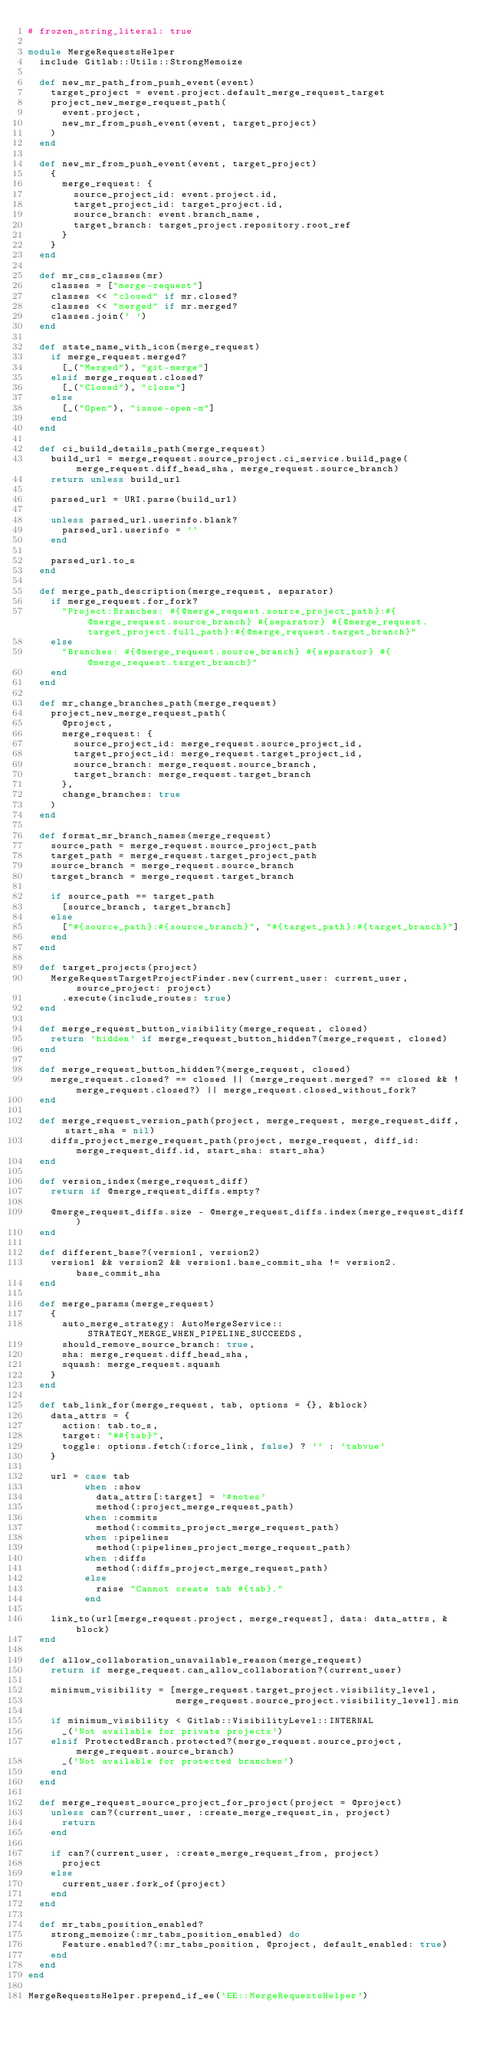Convert code to text. <code><loc_0><loc_0><loc_500><loc_500><_Ruby_># frozen_string_literal: true

module MergeRequestsHelper
  include Gitlab::Utils::StrongMemoize

  def new_mr_path_from_push_event(event)
    target_project = event.project.default_merge_request_target
    project_new_merge_request_path(
      event.project,
      new_mr_from_push_event(event, target_project)
    )
  end

  def new_mr_from_push_event(event, target_project)
    {
      merge_request: {
        source_project_id: event.project.id,
        target_project_id: target_project.id,
        source_branch: event.branch_name,
        target_branch: target_project.repository.root_ref
      }
    }
  end

  def mr_css_classes(mr)
    classes = ["merge-request"]
    classes << "closed" if mr.closed?
    classes << "merged" if mr.merged?
    classes.join(' ')
  end

  def state_name_with_icon(merge_request)
    if merge_request.merged?
      [_("Merged"), "git-merge"]
    elsif merge_request.closed?
      [_("Closed"), "close"]
    else
      [_("Open"), "issue-open-m"]
    end
  end

  def ci_build_details_path(merge_request)
    build_url = merge_request.source_project.ci_service.build_page(merge_request.diff_head_sha, merge_request.source_branch)
    return unless build_url

    parsed_url = URI.parse(build_url)

    unless parsed_url.userinfo.blank?
      parsed_url.userinfo = ''
    end

    parsed_url.to_s
  end

  def merge_path_description(merge_request, separator)
    if merge_request.for_fork?
      "Project:Branches: #{@merge_request.source_project_path}:#{@merge_request.source_branch} #{separator} #{@merge_request.target_project.full_path}:#{@merge_request.target_branch}"
    else
      "Branches: #{@merge_request.source_branch} #{separator} #{@merge_request.target_branch}"
    end
  end

  def mr_change_branches_path(merge_request)
    project_new_merge_request_path(
      @project,
      merge_request: {
        source_project_id: merge_request.source_project_id,
        target_project_id: merge_request.target_project_id,
        source_branch: merge_request.source_branch,
        target_branch: merge_request.target_branch
      },
      change_branches: true
    )
  end

  def format_mr_branch_names(merge_request)
    source_path = merge_request.source_project_path
    target_path = merge_request.target_project_path
    source_branch = merge_request.source_branch
    target_branch = merge_request.target_branch

    if source_path == target_path
      [source_branch, target_branch]
    else
      ["#{source_path}:#{source_branch}", "#{target_path}:#{target_branch}"]
    end
  end

  def target_projects(project)
    MergeRequestTargetProjectFinder.new(current_user: current_user, source_project: project)
      .execute(include_routes: true)
  end

  def merge_request_button_visibility(merge_request, closed)
    return 'hidden' if merge_request_button_hidden?(merge_request, closed)
  end

  def merge_request_button_hidden?(merge_request, closed)
    merge_request.closed? == closed || (merge_request.merged? == closed && !merge_request.closed?) || merge_request.closed_without_fork?
  end

  def merge_request_version_path(project, merge_request, merge_request_diff, start_sha = nil)
    diffs_project_merge_request_path(project, merge_request, diff_id: merge_request_diff.id, start_sha: start_sha)
  end

  def version_index(merge_request_diff)
    return if @merge_request_diffs.empty?

    @merge_request_diffs.size - @merge_request_diffs.index(merge_request_diff)
  end

  def different_base?(version1, version2)
    version1 && version2 && version1.base_commit_sha != version2.base_commit_sha
  end

  def merge_params(merge_request)
    {
      auto_merge_strategy: AutoMergeService::STRATEGY_MERGE_WHEN_PIPELINE_SUCCEEDS,
      should_remove_source_branch: true,
      sha: merge_request.diff_head_sha,
      squash: merge_request.squash
    }
  end

  def tab_link_for(merge_request, tab, options = {}, &block)
    data_attrs = {
      action: tab.to_s,
      target: "##{tab}",
      toggle: options.fetch(:force_link, false) ? '' : 'tabvue'
    }

    url = case tab
          when :show
            data_attrs[:target] = '#notes'
            method(:project_merge_request_path)
          when :commits
            method(:commits_project_merge_request_path)
          when :pipelines
            method(:pipelines_project_merge_request_path)
          when :diffs
            method(:diffs_project_merge_request_path)
          else
            raise "Cannot create tab #{tab}."
          end

    link_to(url[merge_request.project, merge_request], data: data_attrs, &block)
  end

  def allow_collaboration_unavailable_reason(merge_request)
    return if merge_request.can_allow_collaboration?(current_user)

    minimum_visibility = [merge_request.target_project.visibility_level,
                          merge_request.source_project.visibility_level].min

    if minimum_visibility < Gitlab::VisibilityLevel::INTERNAL
      _('Not available for private projects')
    elsif ProtectedBranch.protected?(merge_request.source_project, merge_request.source_branch)
      _('Not available for protected branches')
    end
  end

  def merge_request_source_project_for_project(project = @project)
    unless can?(current_user, :create_merge_request_in, project)
      return
    end

    if can?(current_user, :create_merge_request_from, project)
      project
    else
      current_user.fork_of(project)
    end
  end

  def mr_tabs_position_enabled?
    strong_memoize(:mr_tabs_position_enabled) do
      Feature.enabled?(:mr_tabs_position, @project, default_enabled: true)
    end
  end
end

MergeRequestsHelper.prepend_if_ee('EE::MergeRequestsHelper')
</code> 